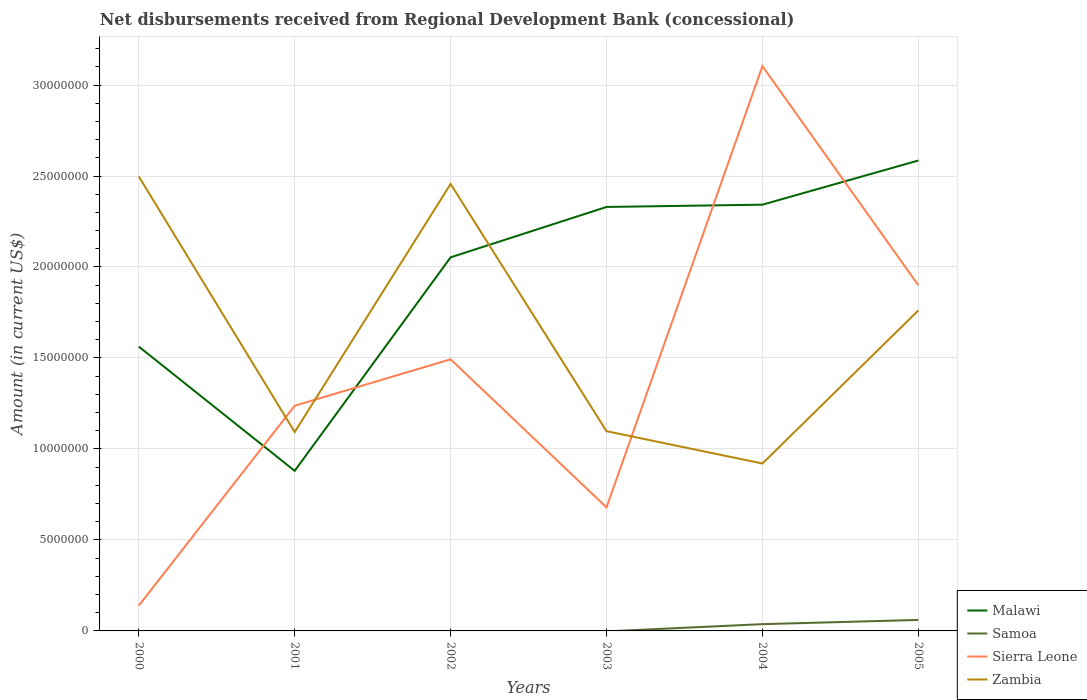Is the number of lines equal to the number of legend labels?
Offer a terse response. No. Across all years, what is the maximum amount of disbursements received from Regional Development Bank in Malawi?
Offer a very short reply. 8.80e+06. What is the total amount of disbursements received from Regional Development Bank in Malawi in the graph?
Give a very brief answer. 6.83e+06. What is the difference between the highest and the second highest amount of disbursements received from Regional Development Bank in Zambia?
Your answer should be very brief. 1.58e+07. What is the difference between the highest and the lowest amount of disbursements received from Regional Development Bank in Zambia?
Offer a terse response. 3. Is the amount of disbursements received from Regional Development Bank in Malawi strictly greater than the amount of disbursements received from Regional Development Bank in Sierra Leone over the years?
Provide a succinct answer. No. How many lines are there?
Offer a terse response. 4. Does the graph contain any zero values?
Provide a short and direct response. Yes. Where does the legend appear in the graph?
Ensure brevity in your answer.  Bottom right. How many legend labels are there?
Your response must be concise. 4. How are the legend labels stacked?
Provide a short and direct response. Vertical. What is the title of the graph?
Ensure brevity in your answer.  Net disbursements received from Regional Development Bank (concessional). Does "Antigua and Barbuda" appear as one of the legend labels in the graph?
Your answer should be very brief. No. What is the label or title of the X-axis?
Provide a succinct answer. Years. What is the Amount (in current US$) of Malawi in 2000?
Ensure brevity in your answer.  1.56e+07. What is the Amount (in current US$) of Sierra Leone in 2000?
Keep it short and to the point. 1.39e+06. What is the Amount (in current US$) in Zambia in 2000?
Provide a short and direct response. 2.50e+07. What is the Amount (in current US$) of Malawi in 2001?
Make the answer very short. 8.80e+06. What is the Amount (in current US$) of Samoa in 2001?
Provide a short and direct response. 0. What is the Amount (in current US$) in Sierra Leone in 2001?
Your answer should be very brief. 1.24e+07. What is the Amount (in current US$) of Zambia in 2001?
Provide a short and direct response. 1.09e+07. What is the Amount (in current US$) of Malawi in 2002?
Your answer should be very brief. 2.05e+07. What is the Amount (in current US$) of Sierra Leone in 2002?
Give a very brief answer. 1.49e+07. What is the Amount (in current US$) in Zambia in 2002?
Provide a succinct answer. 2.46e+07. What is the Amount (in current US$) in Malawi in 2003?
Give a very brief answer. 2.33e+07. What is the Amount (in current US$) of Sierra Leone in 2003?
Give a very brief answer. 6.79e+06. What is the Amount (in current US$) in Zambia in 2003?
Give a very brief answer. 1.10e+07. What is the Amount (in current US$) of Malawi in 2004?
Provide a short and direct response. 2.34e+07. What is the Amount (in current US$) of Samoa in 2004?
Keep it short and to the point. 3.72e+05. What is the Amount (in current US$) of Sierra Leone in 2004?
Ensure brevity in your answer.  3.10e+07. What is the Amount (in current US$) of Zambia in 2004?
Your response must be concise. 9.20e+06. What is the Amount (in current US$) of Malawi in 2005?
Keep it short and to the point. 2.59e+07. What is the Amount (in current US$) in Samoa in 2005?
Keep it short and to the point. 6.04e+05. What is the Amount (in current US$) in Sierra Leone in 2005?
Keep it short and to the point. 1.90e+07. What is the Amount (in current US$) in Zambia in 2005?
Your response must be concise. 1.76e+07. Across all years, what is the maximum Amount (in current US$) of Malawi?
Give a very brief answer. 2.59e+07. Across all years, what is the maximum Amount (in current US$) of Samoa?
Your answer should be very brief. 6.04e+05. Across all years, what is the maximum Amount (in current US$) of Sierra Leone?
Ensure brevity in your answer.  3.10e+07. Across all years, what is the maximum Amount (in current US$) in Zambia?
Keep it short and to the point. 2.50e+07. Across all years, what is the minimum Amount (in current US$) of Malawi?
Your answer should be compact. 8.80e+06. Across all years, what is the minimum Amount (in current US$) in Sierra Leone?
Offer a terse response. 1.39e+06. Across all years, what is the minimum Amount (in current US$) in Zambia?
Provide a succinct answer. 9.20e+06. What is the total Amount (in current US$) of Malawi in the graph?
Your response must be concise. 1.18e+08. What is the total Amount (in current US$) of Samoa in the graph?
Your response must be concise. 9.76e+05. What is the total Amount (in current US$) in Sierra Leone in the graph?
Offer a very short reply. 8.55e+07. What is the total Amount (in current US$) of Zambia in the graph?
Your response must be concise. 9.83e+07. What is the difference between the Amount (in current US$) in Malawi in 2000 and that in 2001?
Make the answer very short. 6.83e+06. What is the difference between the Amount (in current US$) in Sierra Leone in 2000 and that in 2001?
Give a very brief answer. -1.10e+07. What is the difference between the Amount (in current US$) of Zambia in 2000 and that in 2001?
Provide a short and direct response. 1.40e+07. What is the difference between the Amount (in current US$) of Malawi in 2000 and that in 2002?
Your answer should be compact. -4.90e+06. What is the difference between the Amount (in current US$) of Sierra Leone in 2000 and that in 2002?
Offer a terse response. -1.35e+07. What is the difference between the Amount (in current US$) of Zambia in 2000 and that in 2002?
Make the answer very short. 4.13e+05. What is the difference between the Amount (in current US$) in Malawi in 2000 and that in 2003?
Provide a short and direct response. -7.67e+06. What is the difference between the Amount (in current US$) in Sierra Leone in 2000 and that in 2003?
Your answer should be very brief. -5.40e+06. What is the difference between the Amount (in current US$) of Zambia in 2000 and that in 2003?
Provide a short and direct response. 1.40e+07. What is the difference between the Amount (in current US$) of Malawi in 2000 and that in 2004?
Ensure brevity in your answer.  -7.80e+06. What is the difference between the Amount (in current US$) in Sierra Leone in 2000 and that in 2004?
Offer a very short reply. -2.97e+07. What is the difference between the Amount (in current US$) of Zambia in 2000 and that in 2004?
Ensure brevity in your answer.  1.58e+07. What is the difference between the Amount (in current US$) in Malawi in 2000 and that in 2005?
Your answer should be very brief. -1.02e+07. What is the difference between the Amount (in current US$) of Sierra Leone in 2000 and that in 2005?
Your response must be concise. -1.76e+07. What is the difference between the Amount (in current US$) in Zambia in 2000 and that in 2005?
Offer a very short reply. 7.36e+06. What is the difference between the Amount (in current US$) in Malawi in 2001 and that in 2002?
Your answer should be compact. -1.17e+07. What is the difference between the Amount (in current US$) of Sierra Leone in 2001 and that in 2002?
Offer a terse response. -2.55e+06. What is the difference between the Amount (in current US$) in Zambia in 2001 and that in 2002?
Your answer should be compact. -1.36e+07. What is the difference between the Amount (in current US$) in Malawi in 2001 and that in 2003?
Your response must be concise. -1.45e+07. What is the difference between the Amount (in current US$) in Sierra Leone in 2001 and that in 2003?
Provide a short and direct response. 5.59e+06. What is the difference between the Amount (in current US$) in Zambia in 2001 and that in 2003?
Provide a short and direct response. -4.50e+04. What is the difference between the Amount (in current US$) in Malawi in 2001 and that in 2004?
Make the answer very short. -1.46e+07. What is the difference between the Amount (in current US$) of Sierra Leone in 2001 and that in 2004?
Make the answer very short. -1.87e+07. What is the difference between the Amount (in current US$) of Zambia in 2001 and that in 2004?
Your answer should be very brief. 1.73e+06. What is the difference between the Amount (in current US$) of Malawi in 2001 and that in 2005?
Make the answer very short. -1.71e+07. What is the difference between the Amount (in current US$) of Sierra Leone in 2001 and that in 2005?
Provide a succinct answer. -6.62e+06. What is the difference between the Amount (in current US$) in Zambia in 2001 and that in 2005?
Your response must be concise. -6.68e+06. What is the difference between the Amount (in current US$) in Malawi in 2002 and that in 2003?
Keep it short and to the point. -2.77e+06. What is the difference between the Amount (in current US$) in Sierra Leone in 2002 and that in 2003?
Ensure brevity in your answer.  8.14e+06. What is the difference between the Amount (in current US$) in Zambia in 2002 and that in 2003?
Give a very brief answer. 1.36e+07. What is the difference between the Amount (in current US$) in Malawi in 2002 and that in 2004?
Offer a terse response. -2.89e+06. What is the difference between the Amount (in current US$) of Sierra Leone in 2002 and that in 2004?
Your response must be concise. -1.61e+07. What is the difference between the Amount (in current US$) in Zambia in 2002 and that in 2004?
Provide a succinct answer. 1.54e+07. What is the difference between the Amount (in current US$) of Malawi in 2002 and that in 2005?
Offer a terse response. -5.32e+06. What is the difference between the Amount (in current US$) of Sierra Leone in 2002 and that in 2005?
Give a very brief answer. -4.07e+06. What is the difference between the Amount (in current US$) of Zambia in 2002 and that in 2005?
Your answer should be compact. 6.95e+06. What is the difference between the Amount (in current US$) in Malawi in 2003 and that in 2004?
Ensure brevity in your answer.  -1.25e+05. What is the difference between the Amount (in current US$) in Sierra Leone in 2003 and that in 2004?
Offer a terse response. -2.42e+07. What is the difference between the Amount (in current US$) of Zambia in 2003 and that in 2004?
Ensure brevity in your answer.  1.78e+06. What is the difference between the Amount (in current US$) of Malawi in 2003 and that in 2005?
Provide a short and direct response. -2.55e+06. What is the difference between the Amount (in current US$) of Sierra Leone in 2003 and that in 2005?
Offer a terse response. -1.22e+07. What is the difference between the Amount (in current US$) of Zambia in 2003 and that in 2005?
Make the answer very short. -6.64e+06. What is the difference between the Amount (in current US$) in Malawi in 2004 and that in 2005?
Your answer should be very brief. -2.43e+06. What is the difference between the Amount (in current US$) in Samoa in 2004 and that in 2005?
Provide a succinct answer. -2.32e+05. What is the difference between the Amount (in current US$) in Sierra Leone in 2004 and that in 2005?
Provide a succinct answer. 1.20e+07. What is the difference between the Amount (in current US$) of Zambia in 2004 and that in 2005?
Ensure brevity in your answer.  -8.41e+06. What is the difference between the Amount (in current US$) of Malawi in 2000 and the Amount (in current US$) of Sierra Leone in 2001?
Your answer should be very brief. 3.25e+06. What is the difference between the Amount (in current US$) in Malawi in 2000 and the Amount (in current US$) in Zambia in 2001?
Ensure brevity in your answer.  4.69e+06. What is the difference between the Amount (in current US$) in Sierra Leone in 2000 and the Amount (in current US$) in Zambia in 2001?
Offer a terse response. -9.54e+06. What is the difference between the Amount (in current US$) of Malawi in 2000 and the Amount (in current US$) of Sierra Leone in 2002?
Keep it short and to the point. 7.00e+05. What is the difference between the Amount (in current US$) of Malawi in 2000 and the Amount (in current US$) of Zambia in 2002?
Keep it short and to the point. -8.94e+06. What is the difference between the Amount (in current US$) in Sierra Leone in 2000 and the Amount (in current US$) in Zambia in 2002?
Your answer should be compact. -2.32e+07. What is the difference between the Amount (in current US$) in Malawi in 2000 and the Amount (in current US$) in Sierra Leone in 2003?
Your response must be concise. 8.84e+06. What is the difference between the Amount (in current US$) of Malawi in 2000 and the Amount (in current US$) of Zambia in 2003?
Your answer should be very brief. 4.65e+06. What is the difference between the Amount (in current US$) of Sierra Leone in 2000 and the Amount (in current US$) of Zambia in 2003?
Ensure brevity in your answer.  -9.59e+06. What is the difference between the Amount (in current US$) in Malawi in 2000 and the Amount (in current US$) in Samoa in 2004?
Provide a succinct answer. 1.53e+07. What is the difference between the Amount (in current US$) of Malawi in 2000 and the Amount (in current US$) of Sierra Leone in 2004?
Your answer should be very brief. -1.54e+07. What is the difference between the Amount (in current US$) of Malawi in 2000 and the Amount (in current US$) of Zambia in 2004?
Your answer should be very brief. 6.43e+06. What is the difference between the Amount (in current US$) of Sierra Leone in 2000 and the Amount (in current US$) of Zambia in 2004?
Give a very brief answer. -7.81e+06. What is the difference between the Amount (in current US$) of Malawi in 2000 and the Amount (in current US$) of Samoa in 2005?
Offer a very short reply. 1.50e+07. What is the difference between the Amount (in current US$) in Malawi in 2000 and the Amount (in current US$) in Sierra Leone in 2005?
Ensure brevity in your answer.  -3.37e+06. What is the difference between the Amount (in current US$) in Malawi in 2000 and the Amount (in current US$) in Zambia in 2005?
Ensure brevity in your answer.  -1.99e+06. What is the difference between the Amount (in current US$) in Sierra Leone in 2000 and the Amount (in current US$) in Zambia in 2005?
Give a very brief answer. -1.62e+07. What is the difference between the Amount (in current US$) in Malawi in 2001 and the Amount (in current US$) in Sierra Leone in 2002?
Ensure brevity in your answer.  -6.13e+06. What is the difference between the Amount (in current US$) of Malawi in 2001 and the Amount (in current US$) of Zambia in 2002?
Your response must be concise. -1.58e+07. What is the difference between the Amount (in current US$) of Sierra Leone in 2001 and the Amount (in current US$) of Zambia in 2002?
Your answer should be compact. -1.22e+07. What is the difference between the Amount (in current US$) of Malawi in 2001 and the Amount (in current US$) of Sierra Leone in 2003?
Your answer should be very brief. 2.01e+06. What is the difference between the Amount (in current US$) of Malawi in 2001 and the Amount (in current US$) of Zambia in 2003?
Your answer should be compact. -2.18e+06. What is the difference between the Amount (in current US$) of Sierra Leone in 2001 and the Amount (in current US$) of Zambia in 2003?
Make the answer very short. 1.40e+06. What is the difference between the Amount (in current US$) in Malawi in 2001 and the Amount (in current US$) in Samoa in 2004?
Provide a short and direct response. 8.42e+06. What is the difference between the Amount (in current US$) of Malawi in 2001 and the Amount (in current US$) of Sierra Leone in 2004?
Your response must be concise. -2.22e+07. What is the difference between the Amount (in current US$) in Malawi in 2001 and the Amount (in current US$) in Zambia in 2004?
Make the answer very short. -4.03e+05. What is the difference between the Amount (in current US$) of Sierra Leone in 2001 and the Amount (in current US$) of Zambia in 2004?
Offer a terse response. 3.18e+06. What is the difference between the Amount (in current US$) of Malawi in 2001 and the Amount (in current US$) of Samoa in 2005?
Offer a terse response. 8.19e+06. What is the difference between the Amount (in current US$) of Malawi in 2001 and the Amount (in current US$) of Sierra Leone in 2005?
Your response must be concise. -1.02e+07. What is the difference between the Amount (in current US$) of Malawi in 2001 and the Amount (in current US$) of Zambia in 2005?
Offer a terse response. -8.82e+06. What is the difference between the Amount (in current US$) of Sierra Leone in 2001 and the Amount (in current US$) of Zambia in 2005?
Your answer should be compact. -5.24e+06. What is the difference between the Amount (in current US$) in Malawi in 2002 and the Amount (in current US$) in Sierra Leone in 2003?
Your response must be concise. 1.37e+07. What is the difference between the Amount (in current US$) in Malawi in 2002 and the Amount (in current US$) in Zambia in 2003?
Give a very brief answer. 9.55e+06. What is the difference between the Amount (in current US$) of Sierra Leone in 2002 and the Amount (in current US$) of Zambia in 2003?
Provide a succinct answer. 3.95e+06. What is the difference between the Amount (in current US$) of Malawi in 2002 and the Amount (in current US$) of Samoa in 2004?
Your response must be concise. 2.02e+07. What is the difference between the Amount (in current US$) of Malawi in 2002 and the Amount (in current US$) of Sierra Leone in 2004?
Provide a succinct answer. -1.05e+07. What is the difference between the Amount (in current US$) of Malawi in 2002 and the Amount (in current US$) of Zambia in 2004?
Ensure brevity in your answer.  1.13e+07. What is the difference between the Amount (in current US$) in Sierra Leone in 2002 and the Amount (in current US$) in Zambia in 2004?
Your answer should be compact. 5.73e+06. What is the difference between the Amount (in current US$) in Malawi in 2002 and the Amount (in current US$) in Samoa in 2005?
Your answer should be compact. 1.99e+07. What is the difference between the Amount (in current US$) in Malawi in 2002 and the Amount (in current US$) in Sierra Leone in 2005?
Offer a terse response. 1.54e+06. What is the difference between the Amount (in current US$) of Malawi in 2002 and the Amount (in current US$) of Zambia in 2005?
Provide a succinct answer. 2.92e+06. What is the difference between the Amount (in current US$) of Sierra Leone in 2002 and the Amount (in current US$) of Zambia in 2005?
Your answer should be compact. -2.69e+06. What is the difference between the Amount (in current US$) in Malawi in 2003 and the Amount (in current US$) in Samoa in 2004?
Give a very brief answer. 2.29e+07. What is the difference between the Amount (in current US$) in Malawi in 2003 and the Amount (in current US$) in Sierra Leone in 2004?
Offer a very short reply. -7.74e+06. What is the difference between the Amount (in current US$) in Malawi in 2003 and the Amount (in current US$) in Zambia in 2004?
Your answer should be compact. 1.41e+07. What is the difference between the Amount (in current US$) of Sierra Leone in 2003 and the Amount (in current US$) of Zambia in 2004?
Keep it short and to the point. -2.41e+06. What is the difference between the Amount (in current US$) of Malawi in 2003 and the Amount (in current US$) of Samoa in 2005?
Your answer should be very brief. 2.27e+07. What is the difference between the Amount (in current US$) of Malawi in 2003 and the Amount (in current US$) of Sierra Leone in 2005?
Make the answer very short. 4.30e+06. What is the difference between the Amount (in current US$) in Malawi in 2003 and the Amount (in current US$) in Zambia in 2005?
Your answer should be very brief. 5.69e+06. What is the difference between the Amount (in current US$) of Sierra Leone in 2003 and the Amount (in current US$) of Zambia in 2005?
Offer a terse response. -1.08e+07. What is the difference between the Amount (in current US$) in Malawi in 2004 and the Amount (in current US$) in Samoa in 2005?
Offer a very short reply. 2.28e+07. What is the difference between the Amount (in current US$) in Malawi in 2004 and the Amount (in current US$) in Sierra Leone in 2005?
Your answer should be very brief. 4.43e+06. What is the difference between the Amount (in current US$) of Malawi in 2004 and the Amount (in current US$) of Zambia in 2005?
Offer a terse response. 5.81e+06. What is the difference between the Amount (in current US$) of Samoa in 2004 and the Amount (in current US$) of Sierra Leone in 2005?
Give a very brief answer. -1.86e+07. What is the difference between the Amount (in current US$) of Samoa in 2004 and the Amount (in current US$) of Zambia in 2005?
Your response must be concise. -1.72e+07. What is the difference between the Amount (in current US$) of Sierra Leone in 2004 and the Amount (in current US$) of Zambia in 2005?
Offer a terse response. 1.34e+07. What is the average Amount (in current US$) of Malawi per year?
Your answer should be compact. 1.96e+07. What is the average Amount (in current US$) of Samoa per year?
Your response must be concise. 1.63e+05. What is the average Amount (in current US$) in Sierra Leone per year?
Your answer should be very brief. 1.43e+07. What is the average Amount (in current US$) of Zambia per year?
Offer a very short reply. 1.64e+07. In the year 2000, what is the difference between the Amount (in current US$) of Malawi and Amount (in current US$) of Sierra Leone?
Your answer should be compact. 1.42e+07. In the year 2000, what is the difference between the Amount (in current US$) in Malawi and Amount (in current US$) in Zambia?
Provide a succinct answer. -9.35e+06. In the year 2000, what is the difference between the Amount (in current US$) in Sierra Leone and Amount (in current US$) in Zambia?
Provide a short and direct response. -2.36e+07. In the year 2001, what is the difference between the Amount (in current US$) in Malawi and Amount (in current US$) in Sierra Leone?
Give a very brief answer. -3.58e+06. In the year 2001, what is the difference between the Amount (in current US$) in Malawi and Amount (in current US$) in Zambia?
Your response must be concise. -2.14e+06. In the year 2001, what is the difference between the Amount (in current US$) in Sierra Leone and Amount (in current US$) in Zambia?
Your answer should be compact. 1.44e+06. In the year 2002, what is the difference between the Amount (in current US$) of Malawi and Amount (in current US$) of Sierra Leone?
Make the answer very short. 5.60e+06. In the year 2002, what is the difference between the Amount (in current US$) in Malawi and Amount (in current US$) in Zambia?
Offer a very short reply. -4.03e+06. In the year 2002, what is the difference between the Amount (in current US$) in Sierra Leone and Amount (in current US$) in Zambia?
Provide a short and direct response. -9.64e+06. In the year 2003, what is the difference between the Amount (in current US$) of Malawi and Amount (in current US$) of Sierra Leone?
Make the answer very short. 1.65e+07. In the year 2003, what is the difference between the Amount (in current US$) in Malawi and Amount (in current US$) in Zambia?
Keep it short and to the point. 1.23e+07. In the year 2003, what is the difference between the Amount (in current US$) of Sierra Leone and Amount (in current US$) of Zambia?
Offer a very short reply. -4.19e+06. In the year 2004, what is the difference between the Amount (in current US$) of Malawi and Amount (in current US$) of Samoa?
Offer a very short reply. 2.31e+07. In the year 2004, what is the difference between the Amount (in current US$) in Malawi and Amount (in current US$) in Sierra Leone?
Keep it short and to the point. -7.61e+06. In the year 2004, what is the difference between the Amount (in current US$) of Malawi and Amount (in current US$) of Zambia?
Your response must be concise. 1.42e+07. In the year 2004, what is the difference between the Amount (in current US$) of Samoa and Amount (in current US$) of Sierra Leone?
Your answer should be very brief. -3.07e+07. In the year 2004, what is the difference between the Amount (in current US$) in Samoa and Amount (in current US$) in Zambia?
Provide a succinct answer. -8.83e+06. In the year 2004, what is the difference between the Amount (in current US$) in Sierra Leone and Amount (in current US$) in Zambia?
Ensure brevity in your answer.  2.18e+07. In the year 2005, what is the difference between the Amount (in current US$) of Malawi and Amount (in current US$) of Samoa?
Keep it short and to the point. 2.52e+07. In the year 2005, what is the difference between the Amount (in current US$) in Malawi and Amount (in current US$) in Sierra Leone?
Your response must be concise. 6.86e+06. In the year 2005, what is the difference between the Amount (in current US$) of Malawi and Amount (in current US$) of Zambia?
Give a very brief answer. 8.24e+06. In the year 2005, what is the difference between the Amount (in current US$) in Samoa and Amount (in current US$) in Sierra Leone?
Provide a succinct answer. -1.84e+07. In the year 2005, what is the difference between the Amount (in current US$) of Samoa and Amount (in current US$) of Zambia?
Keep it short and to the point. -1.70e+07. In the year 2005, what is the difference between the Amount (in current US$) in Sierra Leone and Amount (in current US$) in Zambia?
Your answer should be compact. 1.38e+06. What is the ratio of the Amount (in current US$) of Malawi in 2000 to that in 2001?
Your response must be concise. 1.78. What is the ratio of the Amount (in current US$) in Sierra Leone in 2000 to that in 2001?
Provide a short and direct response. 0.11. What is the ratio of the Amount (in current US$) of Zambia in 2000 to that in 2001?
Your answer should be compact. 2.28. What is the ratio of the Amount (in current US$) in Malawi in 2000 to that in 2002?
Make the answer very short. 0.76. What is the ratio of the Amount (in current US$) in Sierra Leone in 2000 to that in 2002?
Offer a terse response. 0.09. What is the ratio of the Amount (in current US$) in Zambia in 2000 to that in 2002?
Keep it short and to the point. 1.02. What is the ratio of the Amount (in current US$) of Malawi in 2000 to that in 2003?
Provide a short and direct response. 0.67. What is the ratio of the Amount (in current US$) in Sierra Leone in 2000 to that in 2003?
Give a very brief answer. 0.2. What is the ratio of the Amount (in current US$) in Zambia in 2000 to that in 2003?
Your response must be concise. 2.28. What is the ratio of the Amount (in current US$) of Malawi in 2000 to that in 2004?
Offer a very short reply. 0.67. What is the ratio of the Amount (in current US$) in Sierra Leone in 2000 to that in 2004?
Your answer should be very brief. 0.04. What is the ratio of the Amount (in current US$) in Zambia in 2000 to that in 2004?
Your answer should be very brief. 2.71. What is the ratio of the Amount (in current US$) of Malawi in 2000 to that in 2005?
Ensure brevity in your answer.  0.6. What is the ratio of the Amount (in current US$) of Sierra Leone in 2000 to that in 2005?
Your answer should be very brief. 0.07. What is the ratio of the Amount (in current US$) of Zambia in 2000 to that in 2005?
Give a very brief answer. 1.42. What is the ratio of the Amount (in current US$) of Malawi in 2001 to that in 2002?
Offer a terse response. 0.43. What is the ratio of the Amount (in current US$) of Sierra Leone in 2001 to that in 2002?
Your response must be concise. 0.83. What is the ratio of the Amount (in current US$) in Zambia in 2001 to that in 2002?
Ensure brevity in your answer.  0.45. What is the ratio of the Amount (in current US$) of Malawi in 2001 to that in 2003?
Make the answer very short. 0.38. What is the ratio of the Amount (in current US$) of Sierra Leone in 2001 to that in 2003?
Your answer should be compact. 1.82. What is the ratio of the Amount (in current US$) in Malawi in 2001 to that in 2004?
Your answer should be very brief. 0.38. What is the ratio of the Amount (in current US$) in Sierra Leone in 2001 to that in 2004?
Give a very brief answer. 0.4. What is the ratio of the Amount (in current US$) of Zambia in 2001 to that in 2004?
Your answer should be very brief. 1.19. What is the ratio of the Amount (in current US$) in Malawi in 2001 to that in 2005?
Make the answer very short. 0.34. What is the ratio of the Amount (in current US$) in Sierra Leone in 2001 to that in 2005?
Keep it short and to the point. 0.65. What is the ratio of the Amount (in current US$) of Zambia in 2001 to that in 2005?
Ensure brevity in your answer.  0.62. What is the ratio of the Amount (in current US$) in Malawi in 2002 to that in 2003?
Make the answer very short. 0.88. What is the ratio of the Amount (in current US$) of Sierra Leone in 2002 to that in 2003?
Your answer should be compact. 2.2. What is the ratio of the Amount (in current US$) in Zambia in 2002 to that in 2003?
Your answer should be compact. 2.24. What is the ratio of the Amount (in current US$) of Malawi in 2002 to that in 2004?
Keep it short and to the point. 0.88. What is the ratio of the Amount (in current US$) in Sierra Leone in 2002 to that in 2004?
Keep it short and to the point. 0.48. What is the ratio of the Amount (in current US$) in Zambia in 2002 to that in 2004?
Offer a very short reply. 2.67. What is the ratio of the Amount (in current US$) of Malawi in 2002 to that in 2005?
Ensure brevity in your answer.  0.79. What is the ratio of the Amount (in current US$) in Sierra Leone in 2002 to that in 2005?
Your answer should be compact. 0.79. What is the ratio of the Amount (in current US$) of Zambia in 2002 to that in 2005?
Give a very brief answer. 1.39. What is the ratio of the Amount (in current US$) in Sierra Leone in 2003 to that in 2004?
Your answer should be compact. 0.22. What is the ratio of the Amount (in current US$) of Zambia in 2003 to that in 2004?
Your response must be concise. 1.19. What is the ratio of the Amount (in current US$) in Malawi in 2003 to that in 2005?
Ensure brevity in your answer.  0.9. What is the ratio of the Amount (in current US$) in Sierra Leone in 2003 to that in 2005?
Your answer should be very brief. 0.36. What is the ratio of the Amount (in current US$) in Zambia in 2003 to that in 2005?
Give a very brief answer. 0.62. What is the ratio of the Amount (in current US$) of Malawi in 2004 to that in 2005?
Your response must be concise. 0.91. What is the ratio of the Amount (in current US$) of Samoa in 2004 to that in 2005?
Give a very brief answer. 0.62. What is the ratio of the Amount (in current US$) of Sierra Leone in 2004 to that in 2005?
Give a very brief answer. 1.63. What is the ratio of the Amount (in current US$) of Zambia in 2004 to that in 2005?
Offer a terse response. 0.52. What is the difference between the highest and the second highest Amount (in current US$) in Malawi?
Keep it short and to the point. 2.43e+06. What is the difference between the highest and the second highest Amount (in current US$) in Sierra Leone?
Ensure brevity in your answer.  1.20e+07. What is the difference between the highest and the second highest Amount (in current US$) of Zambia?
Keep it short and to the point. 4.13e+05. What is the difference between the highest and the lowest Amount (in current US$) of Malawi?
Offer a terse response. 1.71e+07. What is the difference between the highest and the lowest Amount (in current US$) in Samoa?
Ensure brevity in your answer.  6.04e+05. What is the difference between the highest and the lowest Amount (in current US$) of Sierra Leone?
Keep it short and to the point. 2.97e+07. What is the difference between the highest and the lowest Amount (in current US$) of Zambia?
Offer a very short reply. 1.58e+07. 